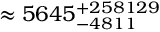Convert formula to latex. <formula><loc_0><loc_0><loc_500><loc_500>\approx 5 6 4 5 _ { - 4 8 1 1 } ^ { + 2 5 8 1 2 9 }</formula> 